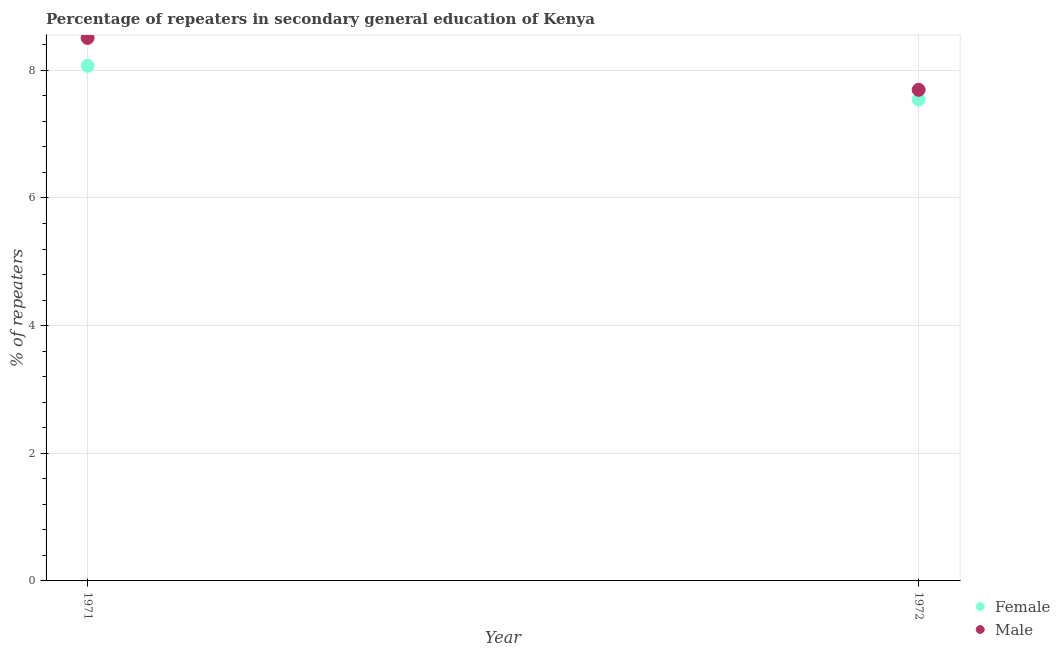How many different coloured dotlines are there?
Your answer should be compact. 2. Is the number of dotlines equal to the number of legend labels?
Give a very brief answer. Yes. What is the percentage of female repeaters in 1971?
Make the answer very short. 8.07. Across all years, what is the maximum percentage of male repeaters?
Your answer should be compact. 8.51. Across all years, what is the minimum percentage of female repeaters?
Offer a terse response. 7.54. In which year was the percentage of female repeaters maximum?
Offer a terse response. 1971. What is the total percentage of female repeaters in the graph?
Your answer should be compact. 15.61. What is the difference between the percentage of male repeaters in 1971 and that in 1972?
Provide a short and direct response. 0.81. What is the difference between the percentage of male repeaters in 1972 and the percentage of female repeaters in 1971?
Give a very brief answer. -0.38. What is the average percentage of male repeaters per year?
Your answer should be very brief. 8.1. In the year 1972, what is the difference between the percentage of male repeaters and percentage of female repeaters?
Offer a very short reply. 0.15. What is the ratio of the percentage of male repeaters in 1971 to that in 1972?
Make the answer very short. 1.11. Is the percentage of female repeaters in 1971 less than that in 1972?
Your response must be concise. No. Does the percentage of male repeaters monotonically increase over the years?
Provide a short and direct response. No. Is the percentage of female repeaters strictly greater than the percentage of male repeaters over the years?
Ensure brevity in your answer.  No. How many dotlines are there?
Provide a short and direct response. 2. What is the difference between two consecutive major ticks on the Y-axis?
Provide a succinct answer. 2. Does the graph contain any zero values?
Give a very brief answer. No. Where does the legend appear in the graph?
Your answer should be compact. Bottom right. How many legend labels are there?
Ensure brevity in your answer.  2. How are the legend labels stacked?
Give a very brief answer. Vertical. What is the title of the graph?
Provide a succinct answer. Percentage of repeaters in secondary general education of Kenya. What is the label or title of the Y-axis?
Keep it short and to the point. % of repeaters. What is the % of repeaters of Female in 1971?
Offer a very short reply. 8.07. What is the % of repeaters in Male in 1971?
Keep it short and to the point. 8.51. What is the % of repeaters in Female in 1972?
Your response must be concise. 7.54. What is the % of repeaters in Male in 1972?
Your response must be concise. 7.69. Across all years, what is the maximum % of repeaters in Female?
Your answer should be very brief. 8.07. Across all years, what is the maximum % of repeaters in Male?
Keep it short and to the point. 8.51. Across all years, what is the minimum % of repeaters of Female?
Your answer should be very brief. 7.54. Across all years, what is the minimum % of repeaters of Male?
Ensure brevity in your answer.  7.69. What is the total % of repeaters of Female in the graph?
Give a very brief answer. 15.61. What is the total % of repeaters in Male in the graph?
Keep it short and to the point. 16.2. What is the difference between the % of repeaters in Female in 1971 and that in 1972?
Your answer should be very brief. 0.53. What is the difference between the % of repeaters of Male in 1971 and that in 1972?
Your answer should be very brief. 0.81. What is the difference between the % of repeaters in Female in 1971 and the % of repeaters in Male in 1972?
Provide a short and direct response. 0.38. What is the average % of repeaters of Female per year?
Provide a succinct answer. 7.81. What is the average % of repeaters of Male per year?
Give a very brief answer. 8.1. In the year 1971, what is the difference between the % of repeaters in Female and % of repeaters in Male?
Your response must be concise. -0.44. In the year 1972, what is the difference between the % of repeaters of Female and % of repeaters of Male?
Offer a very short reply. -0.15. What is the ratio of the % of repeaters in Female in 1971 to that in 1972?
Give a very brief answer. 1.07. What is the ratio of the % of repeaters of Male in 1971 to that in 1972?
Provide a succinct answer. 1.11. What is the difference between the highest and the second highest % of repeaters of Female?
Your answer should be compact. 0.53. What is the difference between the highest and the second highest % of repeaters in Male?
Offer a terse response. 0.81. What is the difference between the highest and the lowest % of repeaters in Female?
Keep it short and to the point. 0.53. What is the difference between the highest and the lowest % of repeaters of Male?
Your response must be concise. 0.81. 